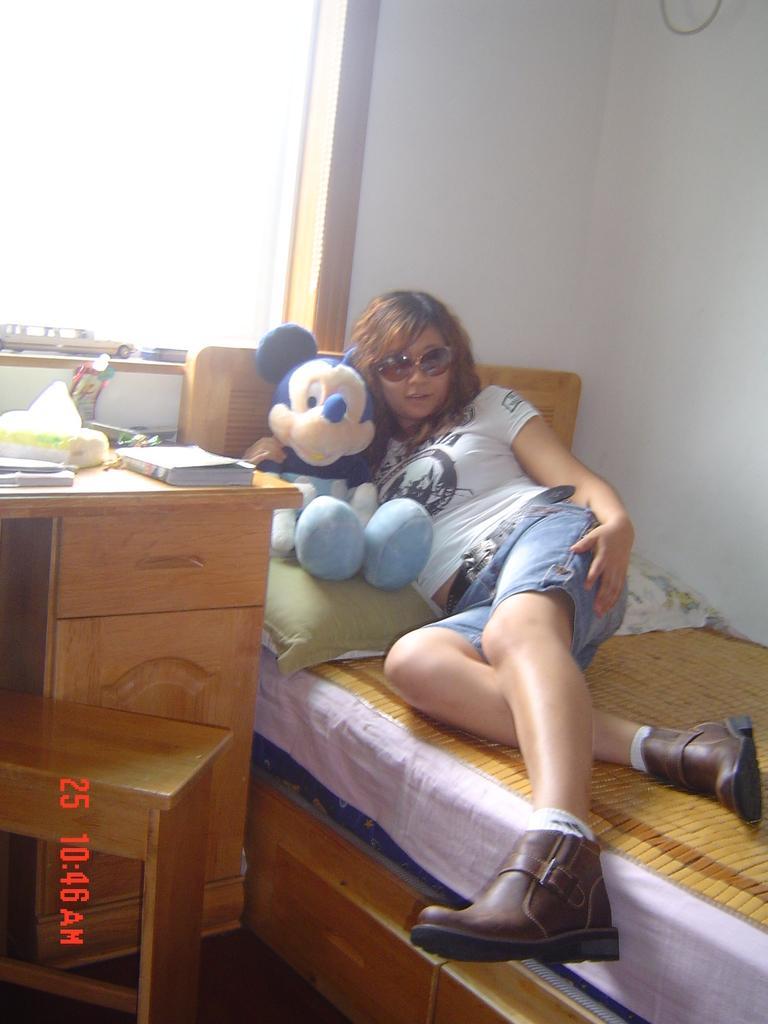How would you summarize this image in a sentence or two? In this picture there is a woman who is lying on the bed. She is wearing goggle, t-shirt, short and shoes. Beside her I can see the mickey mouse doll, pillows and bed sheet. On the table I can see the books, papers, tissue paper, light and other objects. Beside that there is a shed. In the top left I can see some cars toy which are kept on the wooden frame near to the window. In the top right corner there is a wire. In the bottom left corner I can see the watermark. 